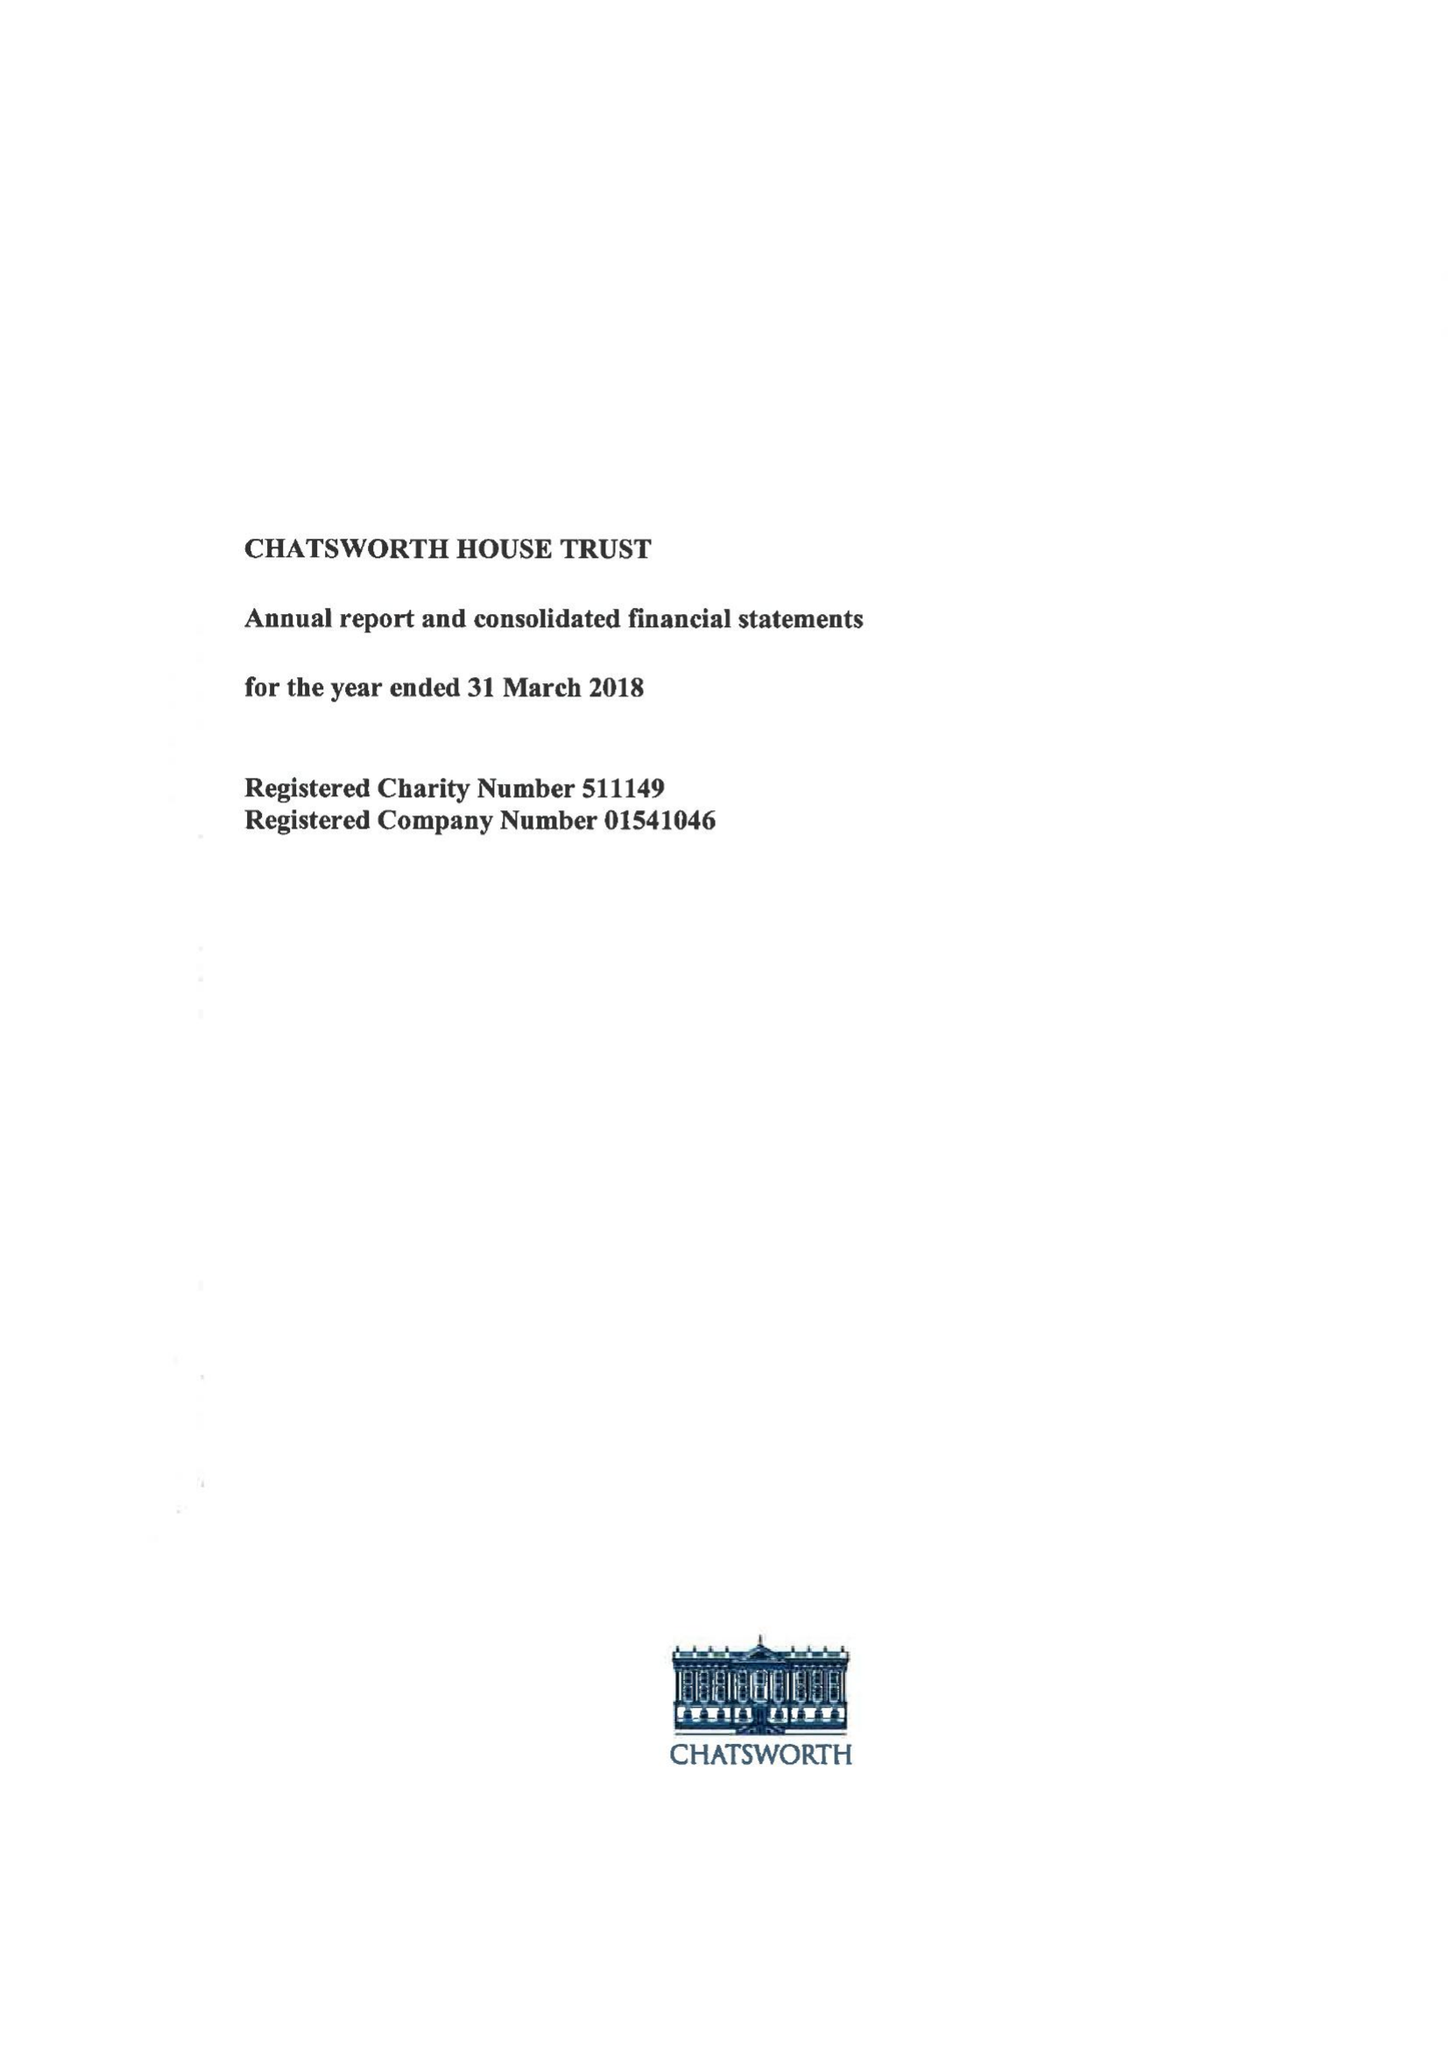What is the value for the spending_annually_in_british_pounds?
Answer the question using a single word or phrase. 16121000.00 